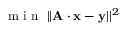<formula> <loc_0><loc_0><loc_500><loc_500>m i n \, | | A \cdot x - y | | ^ { 2 }</formula> 